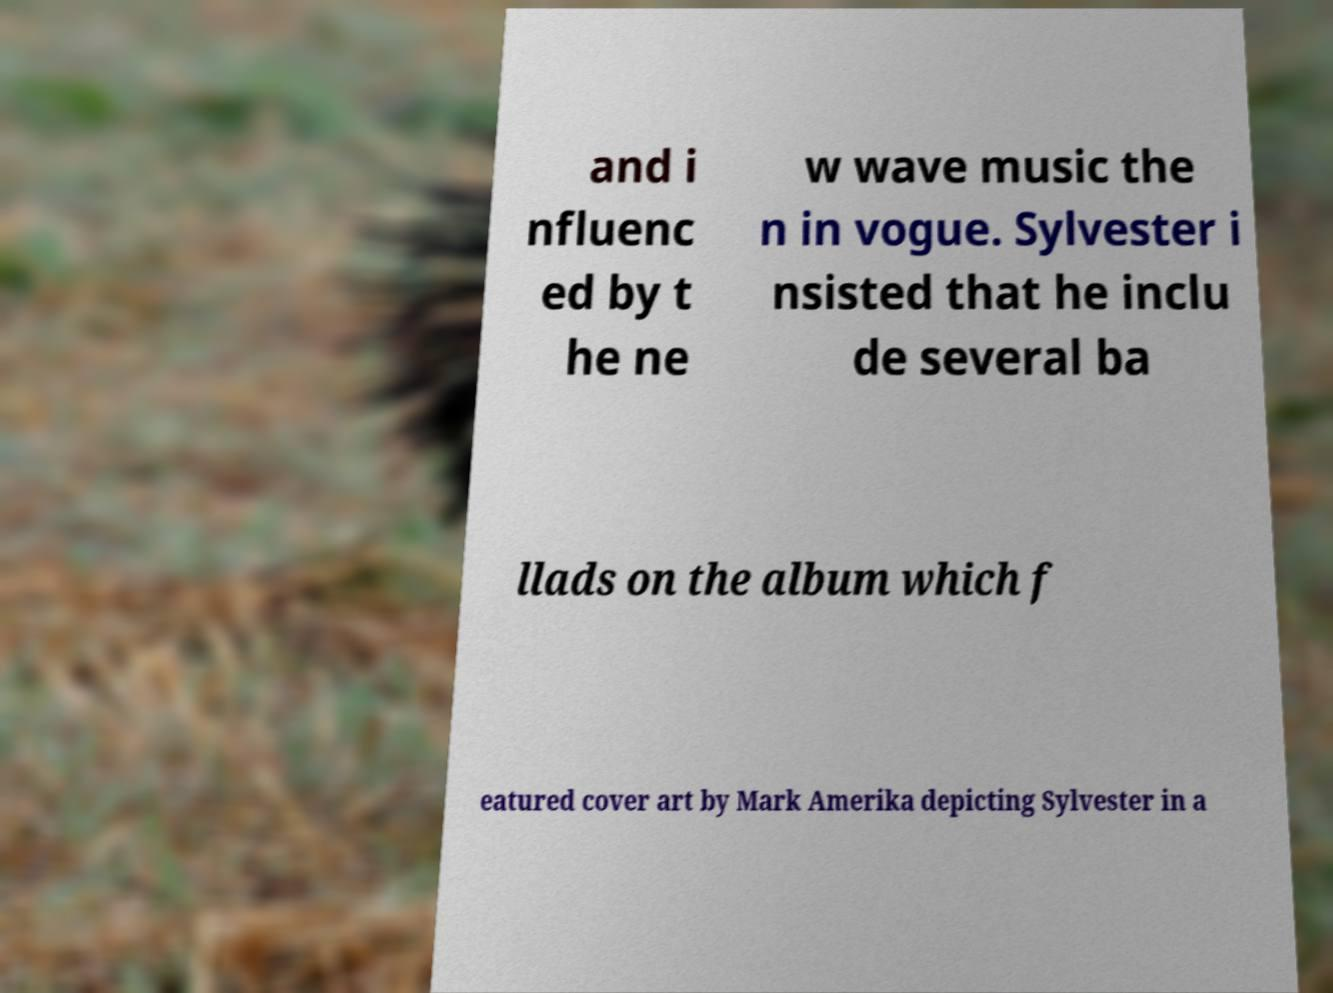Could you extract and type out the text from this image? and i nfluenc ed by t he ne w wave music the n in vogue. Sylvester i nsisted that he inclu de several ba llads on the album which f eatured cover art by Mark Amerika depicting Sylvester in a 